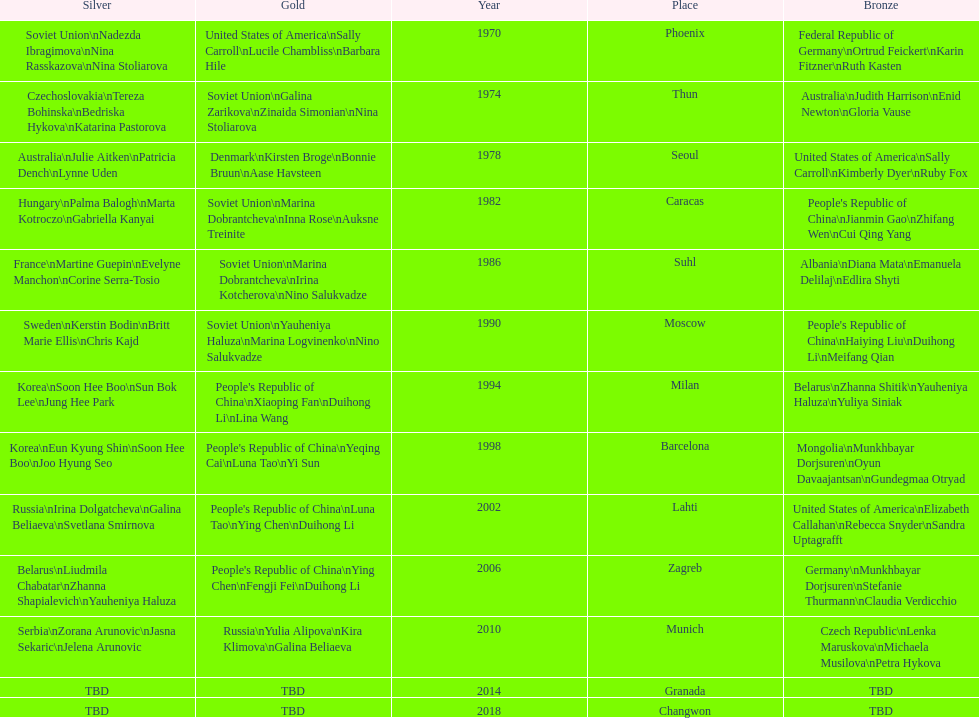Which nation has the highest occurrence in the silver column? Korea. 